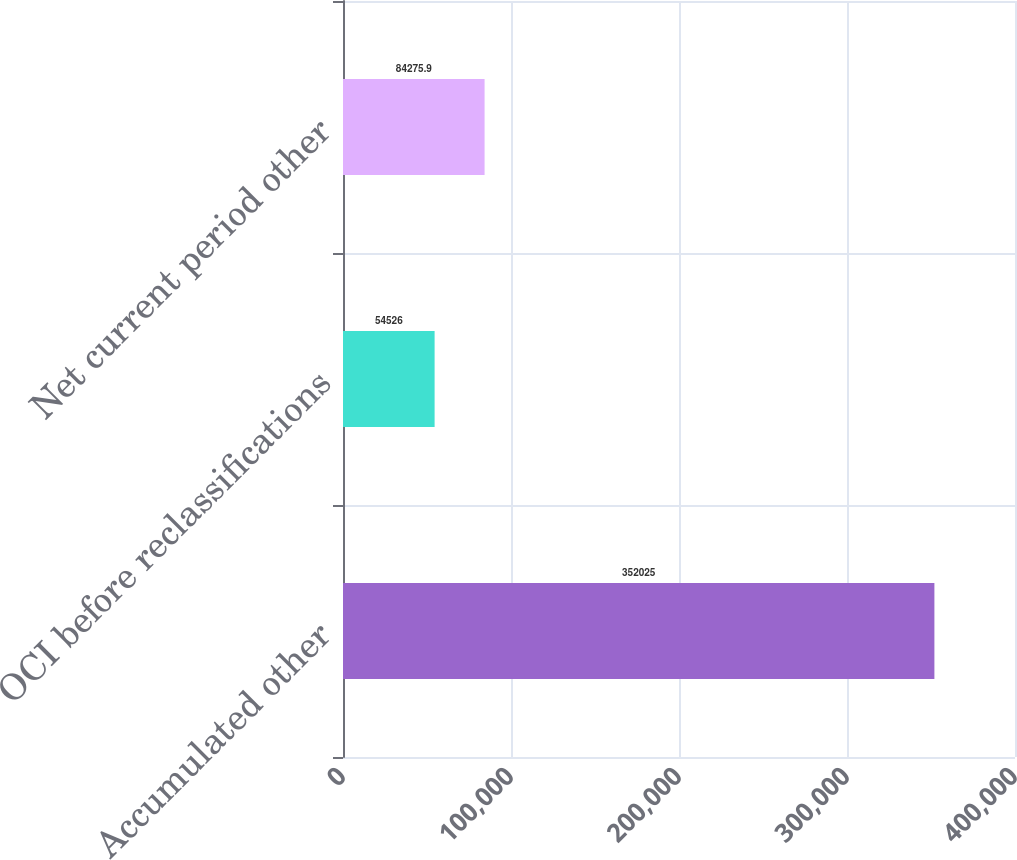<chart> <loc_0><loc_0><loc_500><loc_500><bar_chart><fcel>Accumulated other<fcel>OCI before reclassifications<fcel>Net current period other<nl><fcel>352025<fcel>54526<fcel>84275.9<nl></chart> 